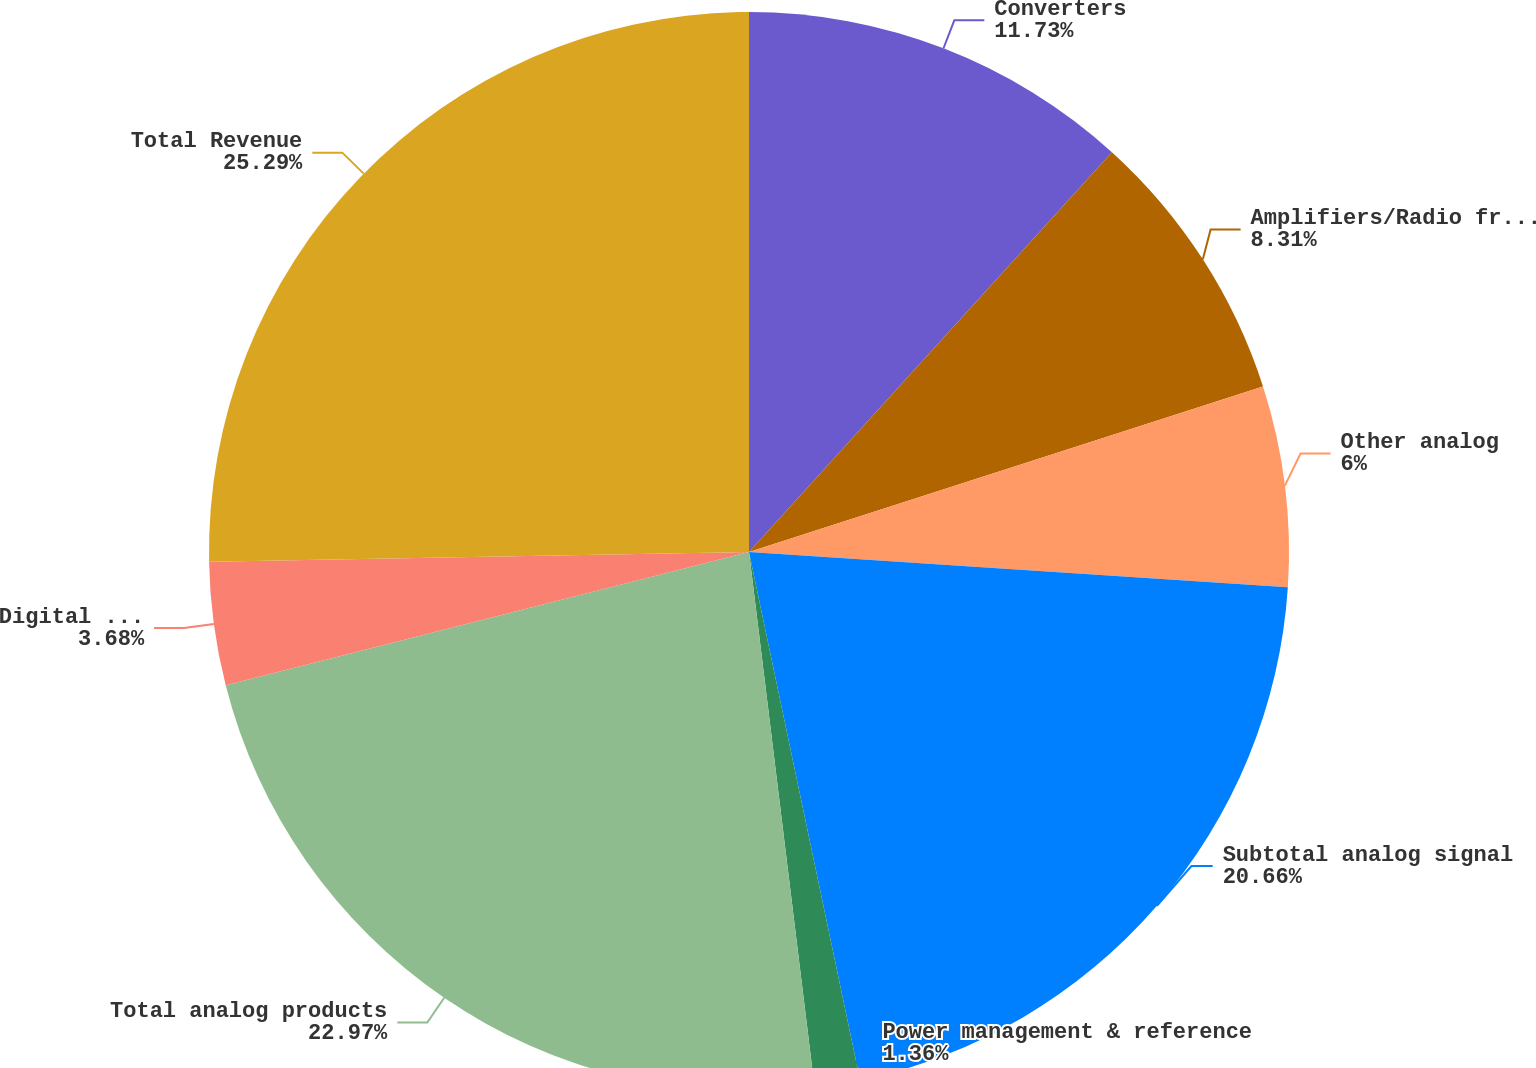<chart> <loc_0><loc_0><loc_500><loc_500><pie_chart><fcel>Converters<fcel>Amplifiers/Radio frequency<fcel>Other analog<fcel>Subtotal analog signal<fcel>Power management & reference<fcel>Total analog products<fcel>Digital signal processing<fcel>Total Revenue<nl><fcel>11.73%<fcel>8.31%<fcel>6.0%<fcel>20.66%<fcel>1.36%<fcel>22.97%<fcel>3.68%<fcel>25.29%<nl></chart> 